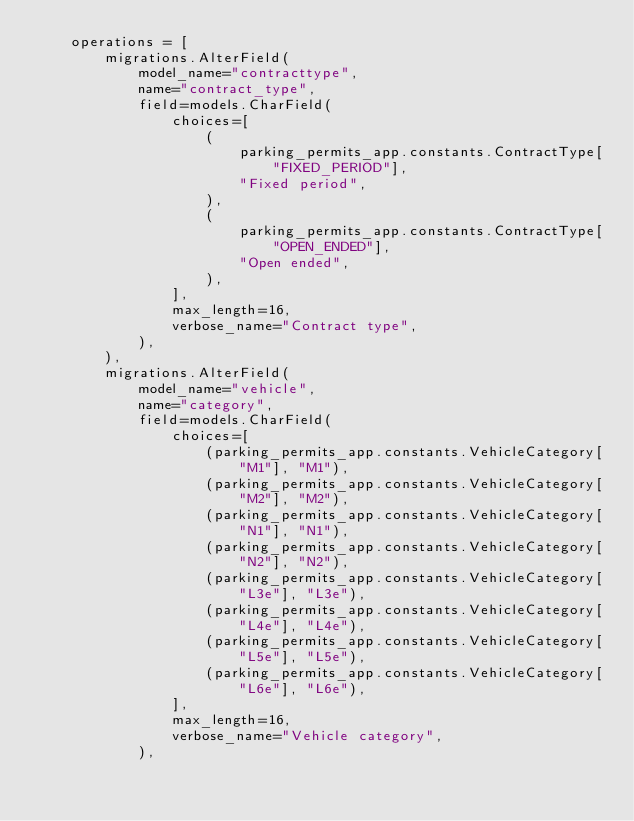Convert code to text. <code><loc_0><loc_0><loc_500><loc_500><_Python_>    operations = [
        migrations.AlterField(
            model_name="contracttype",
            name="contract_type",
            field=models.CharField(
                choices=[
                    (
                        parking_permits_app.constants.ContractType["FIXED_PERIOD"],
                        "Fixed period",
                    ),
                    (
                        parking_permits_app.constants.ContractType["OPEN_ENDED"],
                        "Open ended",
                    ),
                ],
                max_length=16,
                verbose_name="Contract type",
            ),
        ),
        migrations.AlterField(
            model_name="vehicle",
            name="category",
            field=models.CharField(
                choices=[
                    (parking_permits_app.constants.VehicleCategory["M1"], "M1"),
                    (parking_permits_app.constants.VehicleCategory["M2"], "M2"),
                    (parking_permits_app.constants.VehicleCategory["N1"], "N1"),
                    (parking_permits_app.constants.VehicleCategory["N2"], "N2"),
                    (parking_permits_app.constants.VehicleCategory["L3e"], "L3e"),
                    (parking_permits_app.constants.VehicleCategory["L4e"], "L4e"),
                    (parking_permits_app.constants.VehicleCategory["L5e"], "L5e"),
                    (parking_permits_app.constants.VehicleCategory["L6e"], "L6e"),
                ],
                max_length=16,
                verbose_name="Vehicle category",
            ),</code> 